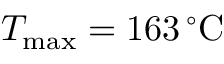<formula> <loc_0><loc_0><loc_500><loc_500>T _ { \max } = 1 6 3 \, ^ { \circ } C</formula> 